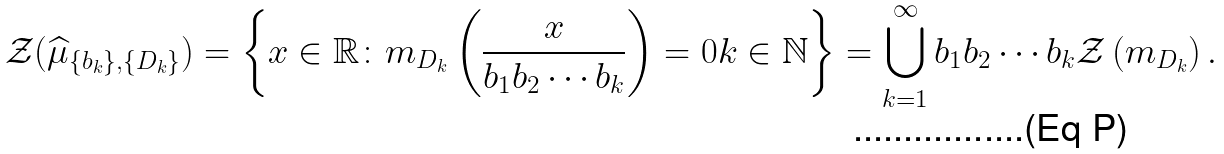Convert formula to latex. <formula><loc_0><loc_0><loc_500><loc_500>\mathcal { Z } ( \widehat { \mu } _ { \{ b _ { k } \} , \{ D _ { k } \} } ) = \left \{ x \in \mathbb { R } \colon m _ { D _ { k } } \left ( \frac { x } { b _ { 1 } b _ { 2 } \cdots b _ { k } } \right ) = 0 k \in \mathbb { N } \right \} = \bigcup _ { k = 1 } ^ { \infty } b _ { 1 } b _ { 2 } \cdots b _ { k } \mathcal { Z } \left ( m _ { D _ { k } } \right ) .</formula> 